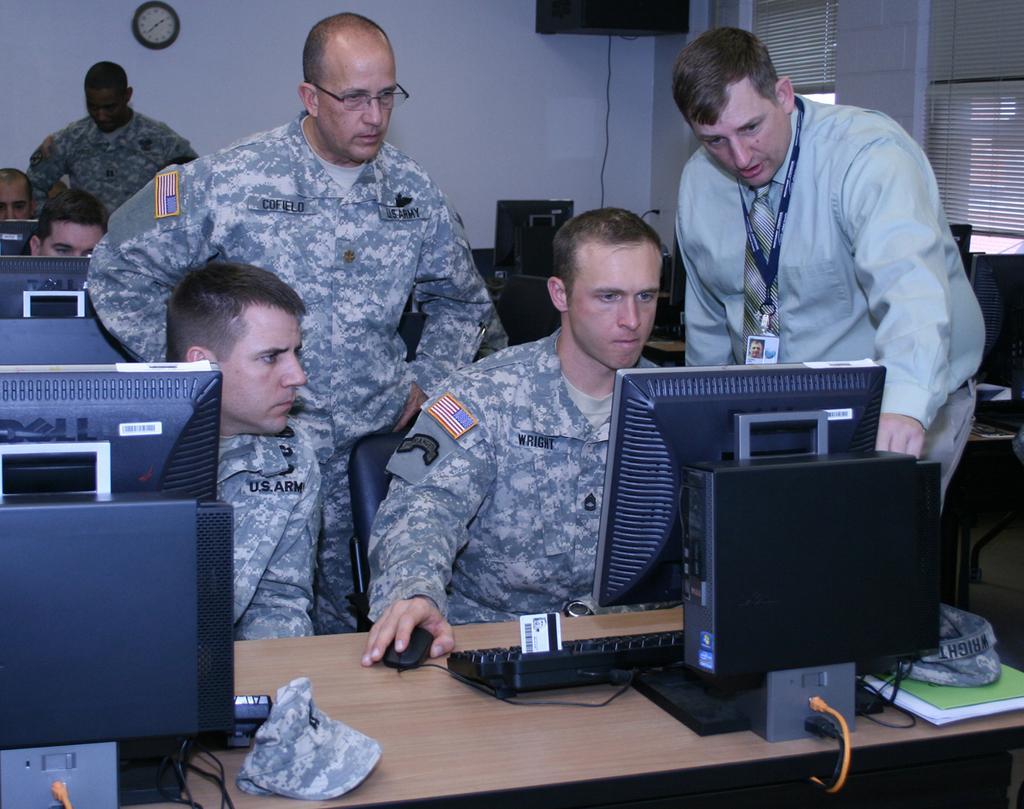In one or two sentences, can you explain what this image depicts? This picture consists of inside view of building , in the building I can see few persons sitting on chair and few persons standing and I can see a table in the foreground and I can see a system , book and key pad and mouse and cap and CPU and cable cards kept on table and I can see there are systems visible in the middle ,at the top I can see the wall, on the wall I can see clock attached , in the top right I can see window. 